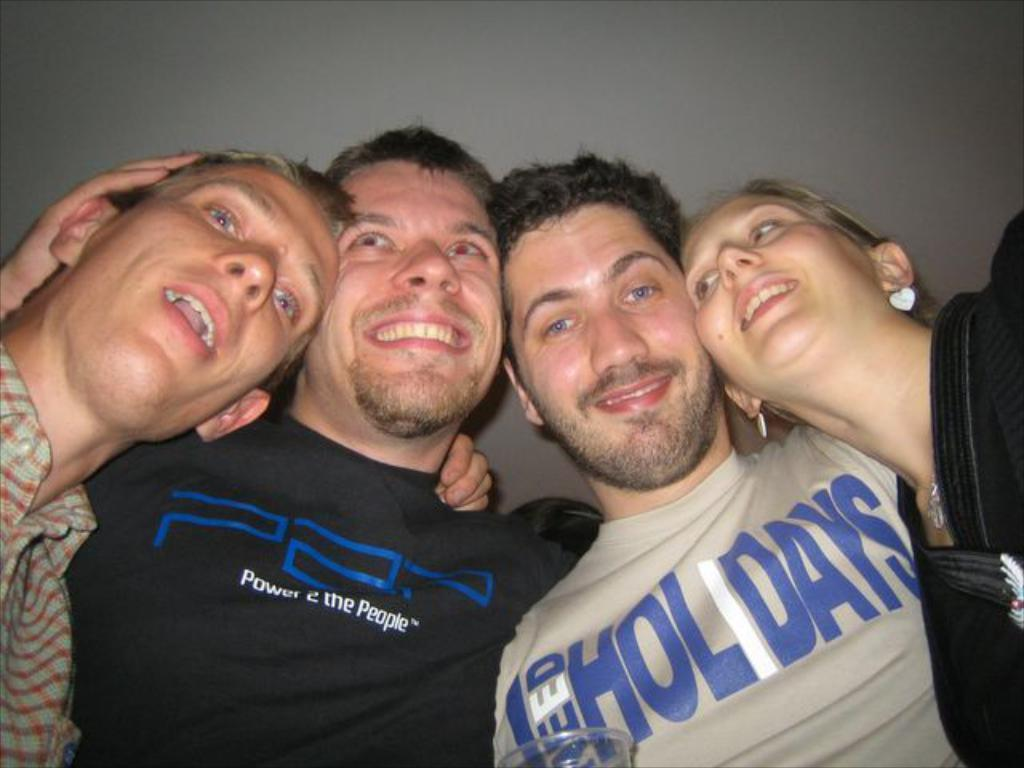How many people are in the image? There are four persons in the image. What are the persons doing in the image? The persons are standing. What is the facial expression of the persons in the image? The persons are smiling. What type of invention can be seen in the hands of the persons in the image? There is no invention present in the image; the persons are simply standing and smiling. 